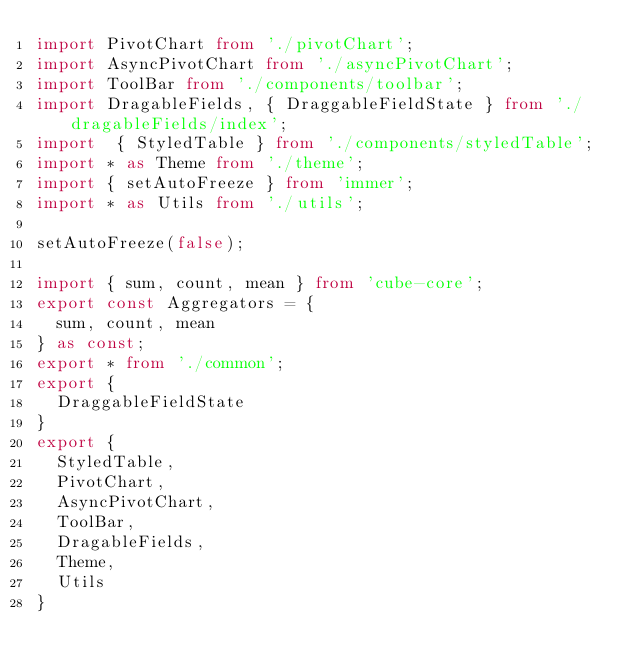<code> <loc_0><loc_0><loc_500><loc_500><_TypeScript_>import PivotChart from './pivotChart';
import AsyncPivotChart from './asyncPivotChart';
import ToolBar from './components/toolbar';
import DragableFields, { DraggableFieldState } from './dragableFields/index';
import  { StyledTable } from './components/styledTable';
import * as Theme from './theme';
import { setAutoFreeze } from 'immer';
import * as Utils from './utils';

setAutoFreeze(false);

import { sum, count, mean } from 'cube-core';
export const Aggregators = {
  sum, count, mean
} as const;
export * from './common';
export {
  DraggableFieldState
}
export {
  StyledTable,
  PivotChart,
  AsyncPivotChart,
  ToolBar,
  DragableFields,
  Theme,
  Utils
}</code> 